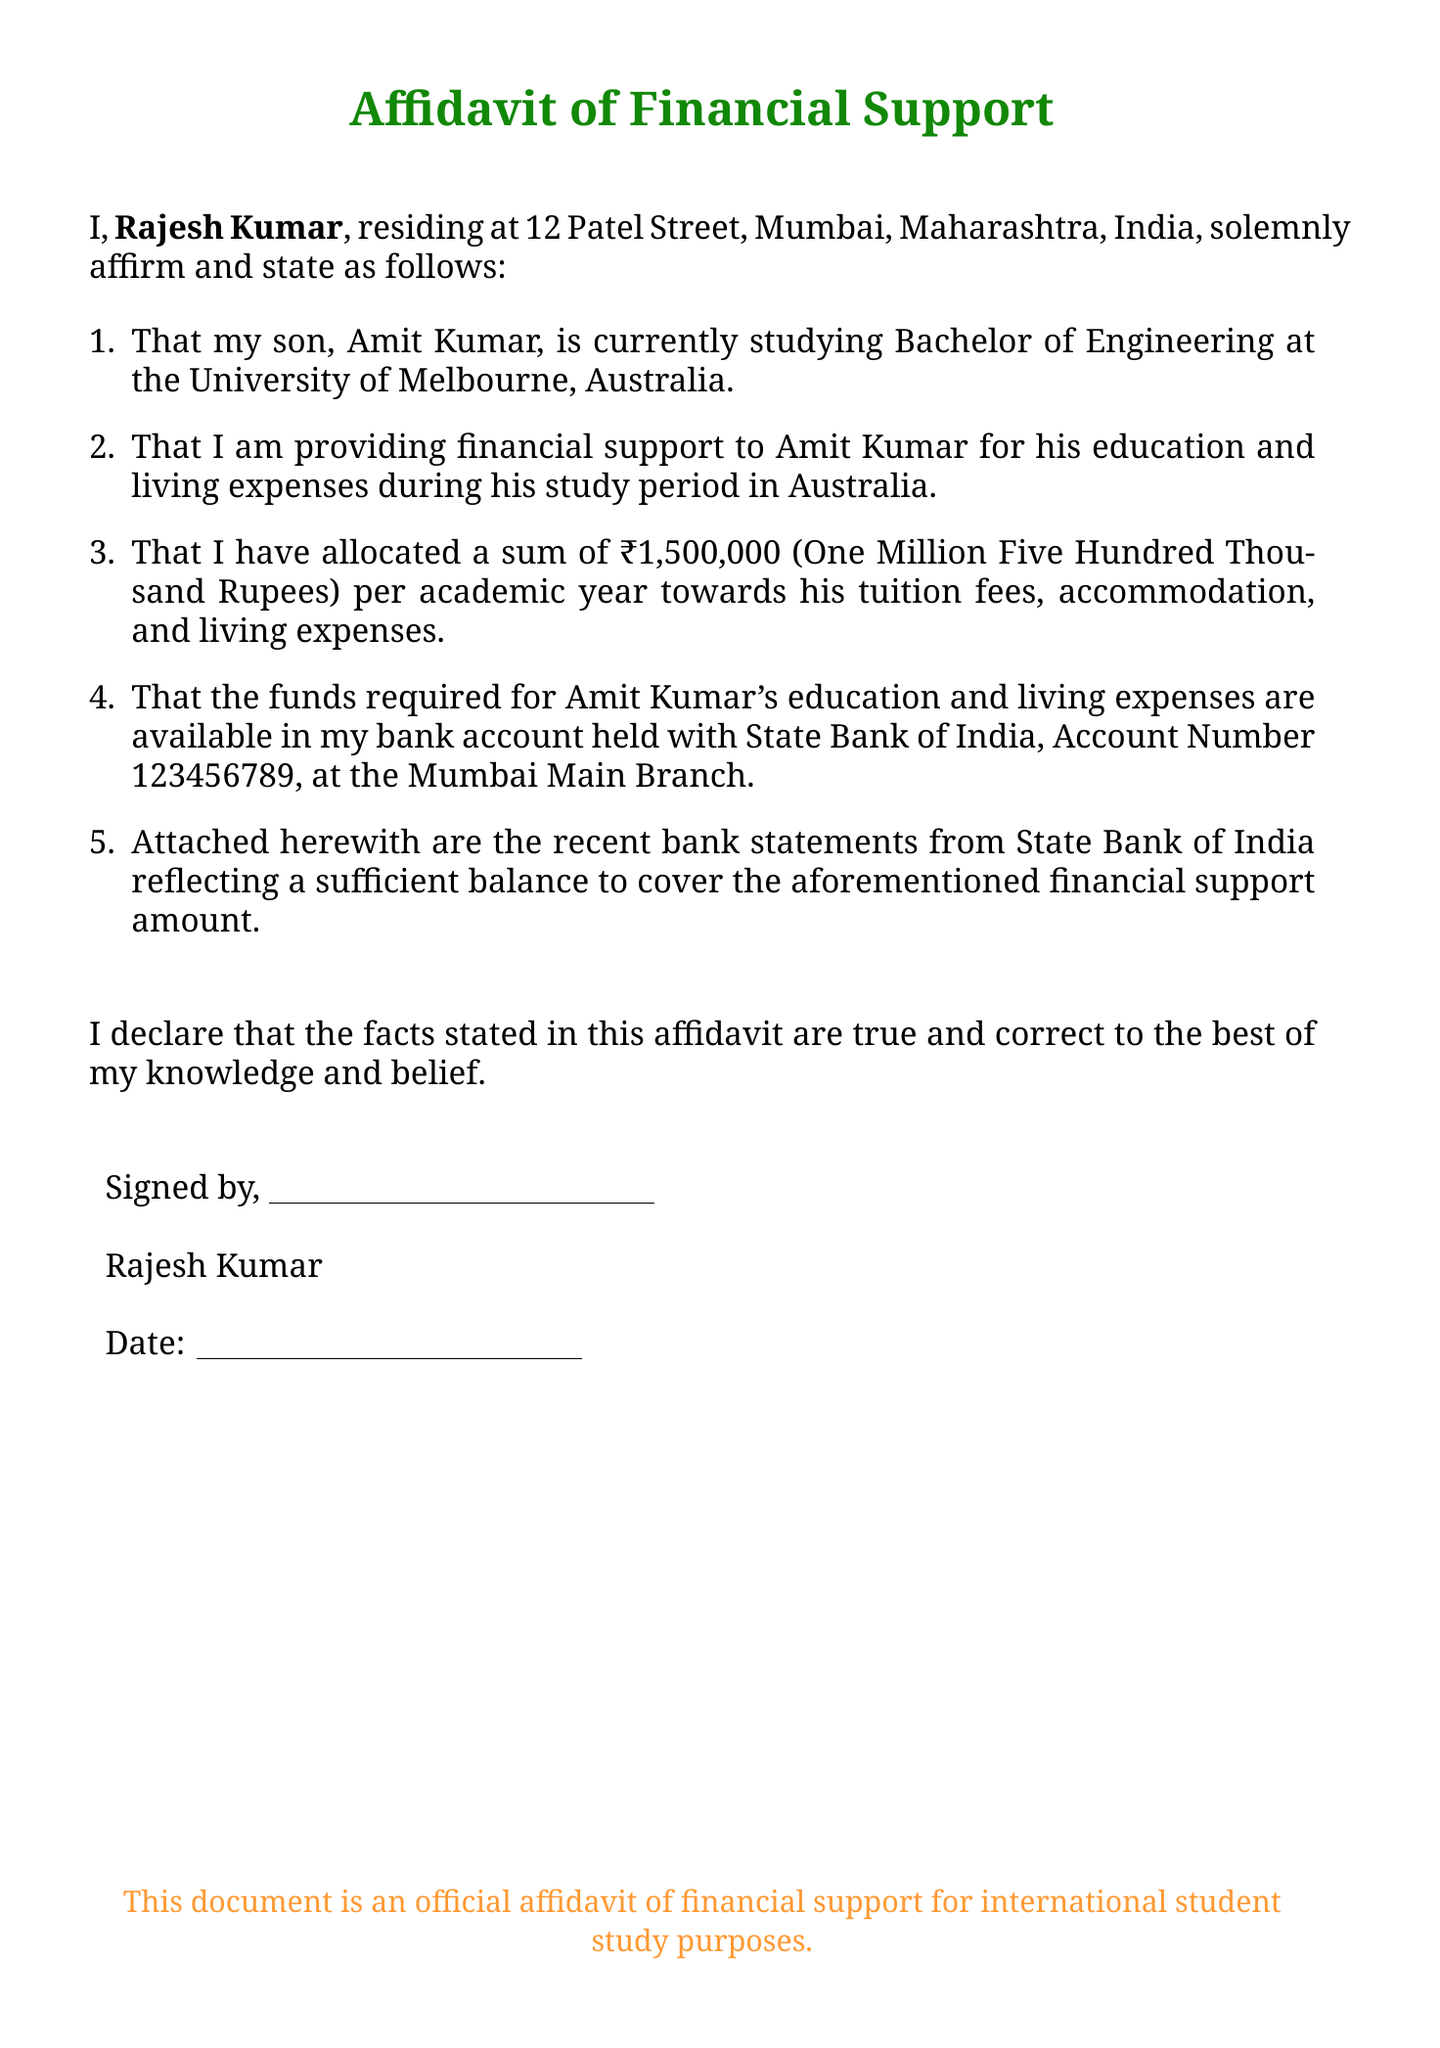What is the name of the person providing financial support? The affidavit states that the person providing financial support is Rajesh Kumar.
Answer: Rajesh Kumar What is the relationship of Amit Kumar to Rajesh Kumar? The affidavit describes Amit Kumar as Rajesh Kumar's son.
Answer: Son Which university is Amit Kumar attending? The document mentions that Amit Kumar is studying at the University of Melbourne.
Answer: University of Melbourne How much financial support is Rajesh Kumar providing per academic year? The affidavit specifies that ₹1,500,000 is allocated as financial support per academic year.
Answer: ₹1,500,000 What is the name of the bank where Rajesh Kumar holds an account? The document indicates that Rajesh Kumar has an account with the State Bank of India.
Answer: State Bank of India What is the account number mentioned in the affidavit? The affidavit includes the account number 123456789 for Rajesh Kumar's bank account.
Answer: 123456789 What is stated about the sufficiency of funds? The document states that the bank statements reflect a sufficient balance to cover the financial support amount.
Answer: Sufficient balance What type of document is this? The document is identified as an official affidavit of financial support for study purposes.
Answer: Affidavit of Financial Support 